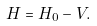<formula> <loc_0><loc_0><loc_500><loc_500>H = H _ { 0 } - V .</formula> 